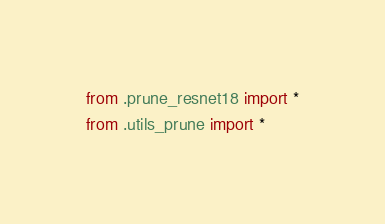<code> <loc_0><loc_0><loc_500><loc_500><_Python_>from .prune_resnet18 import *
from .utils_prune import *</code> 